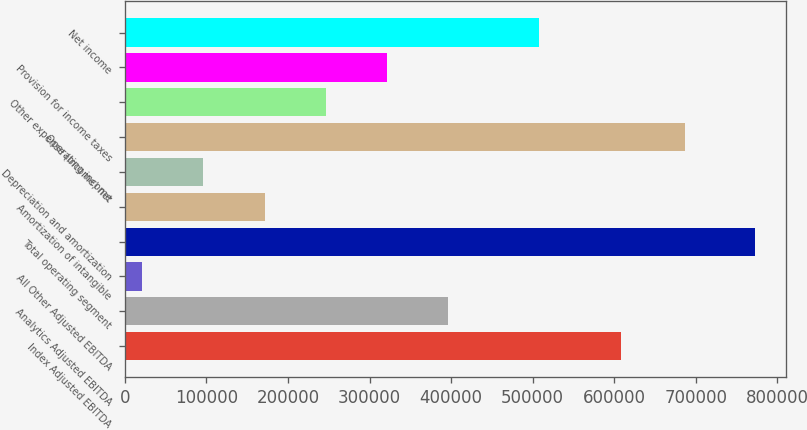Convert chart to OTSL. <chart><loc_0><loc_0><loc_500><loc_500><bar_chart><fcel>Index Adjusted EBITDA<fcel>Analytics Adjusted EBITDA<fcel>All Other Adjusted EBITDA<fcel>Total operating segment<fcel>Amortization of intangible<fcel>Depreciation and amortization<fcel>Operating income<fcel>Other expense (income) net<fcel>Provision for income taxes<fcel>Net income<nl><fcel>607853<fcel>396684<fcel>20935<fcel>772433<fcel>171235<fcel>96084.8<fcel>686898<fcel>246384<fcel>321534<fcel>507885<nl></chart> 